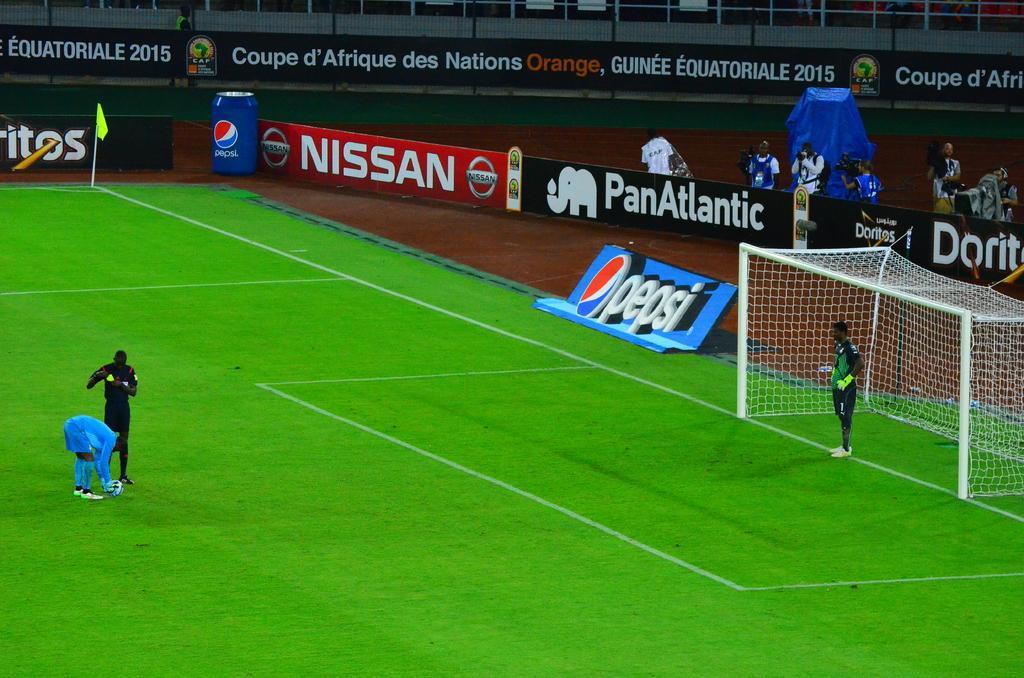Can you describe this image briefly? In the foreground of this image, on the left, there are two men standing on the grass and a man is holding a ball. On the right, there is a man standing in front of a goal net. In the background, there is a boundary banner, a flag, few persons standing behind the banner, a blue cover and the railing at the top. 